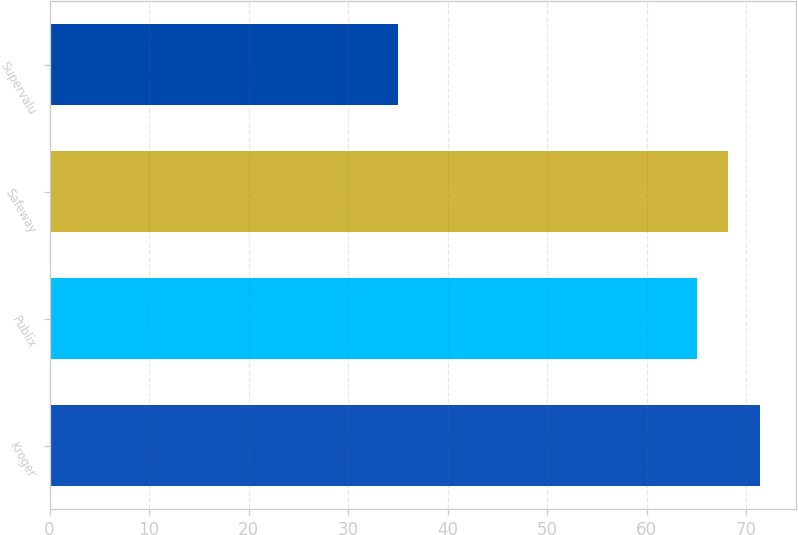<chart> <loc_0><loc_0><loc_500><loc_500><bar_chart><fcel>Kroger<fcel>Publix<fcel>Safeway<fcel>Supervalu<nl><fcel>71.4<fcel>65<fcel>68.2<fcel>35<nl></chart> 